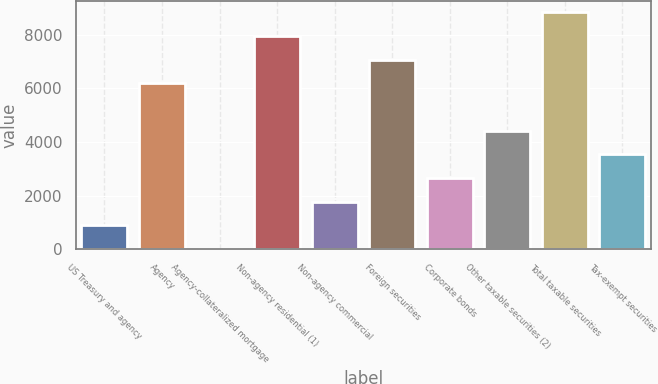Convert chart. <chart><loc_0><loc_0><loc_500><loc_500><bar_chart><fcel>US Treasury and agency<fcel>Agency<fcel>Agency-collateralized mortgage<fcel>Non-agency residential (1)<fcel>Non-agency commercial<fcel>Foreign securities<fcel>Corporate bonds<fcel>Other taxable securities (2)<fcel>Total taxable securities<fcel>Tax-exempt securities<nl><fcel>894.2<fcel>6181.4<fcel>13<fcel>7943.8<fcel>1775.4<fcel>7062.6<fcel>2656.6<fcel>4419<fcel>8825<fcel>3537.8<nl></chart> 